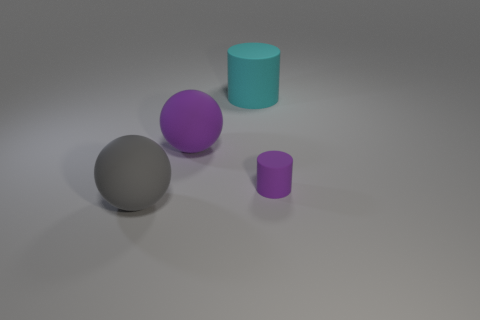What is the size of the ball that is the same color as the small object?
Keep it short and to the point. Large. Is the color of the tiny object the same as the large rubber ball to the right of the gray matte object?
Give a very brief answer. Yes. Are there any large matte objects that have the same color as the small cylinder?
Your response must be concise. Yes. What is the color of the matte object to the right of the large cyan thing that is behind the large matte ball that is on the right side of the large gray matte sphere?
Ensure brevity in your answer.  Purple. Do the big cyan thing and the big sphere in front of the purple matte ball have the same material?
Your response must be concise. Yes. What material is the big cylinder?
Your response must be concise. Rubber. What material is the big object that is the same color as the small rubber thing?
Make the answer very short. Rubber. What number of other objects are the same material as the purple ball?
Offer a very short reply. 3. The rubber thing that is in front of the big purple object and right of the big gray matte sphere has what shape?
Provide a succinct answer. Cylinder. There is a large cylinder that is made of the same material as the tiny purple cylinder; what is its color?
Give a very brief answer. Cyan. 